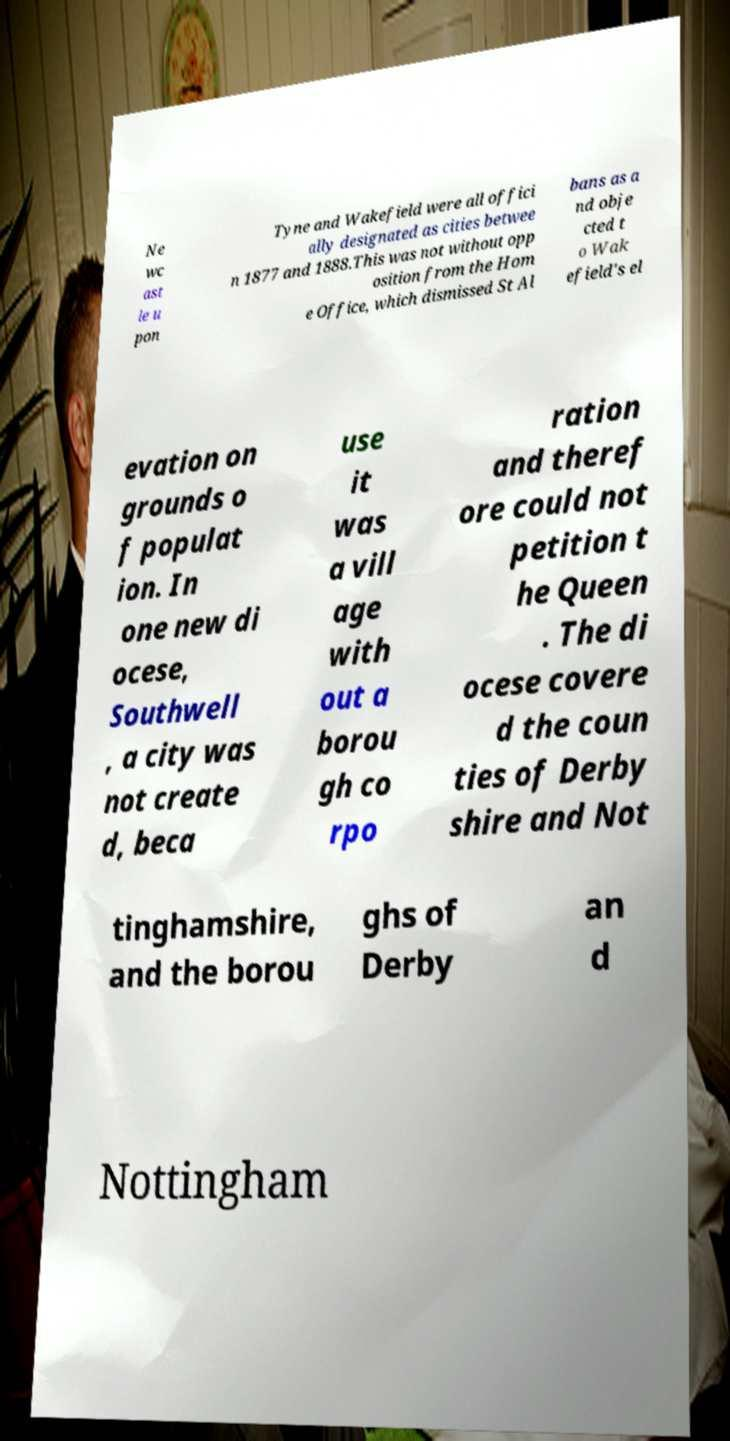For documentation purposes, I need the text within this image transcribed. Could you provide that? Ne wc ast le u pon Tyne and Wakefield were all offici ally designated as cities betwee n 1877 and 1888.This was not without opp osition from the Hom e Office, which dismissed St Al bans as a nd obje cted t o Wak efield's el evation on grounds o f populat ion. In one new di ocese, Southwell , a city was not create d, beca use it was a vill age with out a borou gh co rpo ration and theref ore could not petition t he Queen . The di ocese covere d the coun ties of Derby shire and Not tinghamshire, and the borou ghs of Derby an d Nottingham 